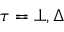<formula> <loc_0><loc_0><loc_500><loc_500>\tau = \bot , \Delta</formula> 